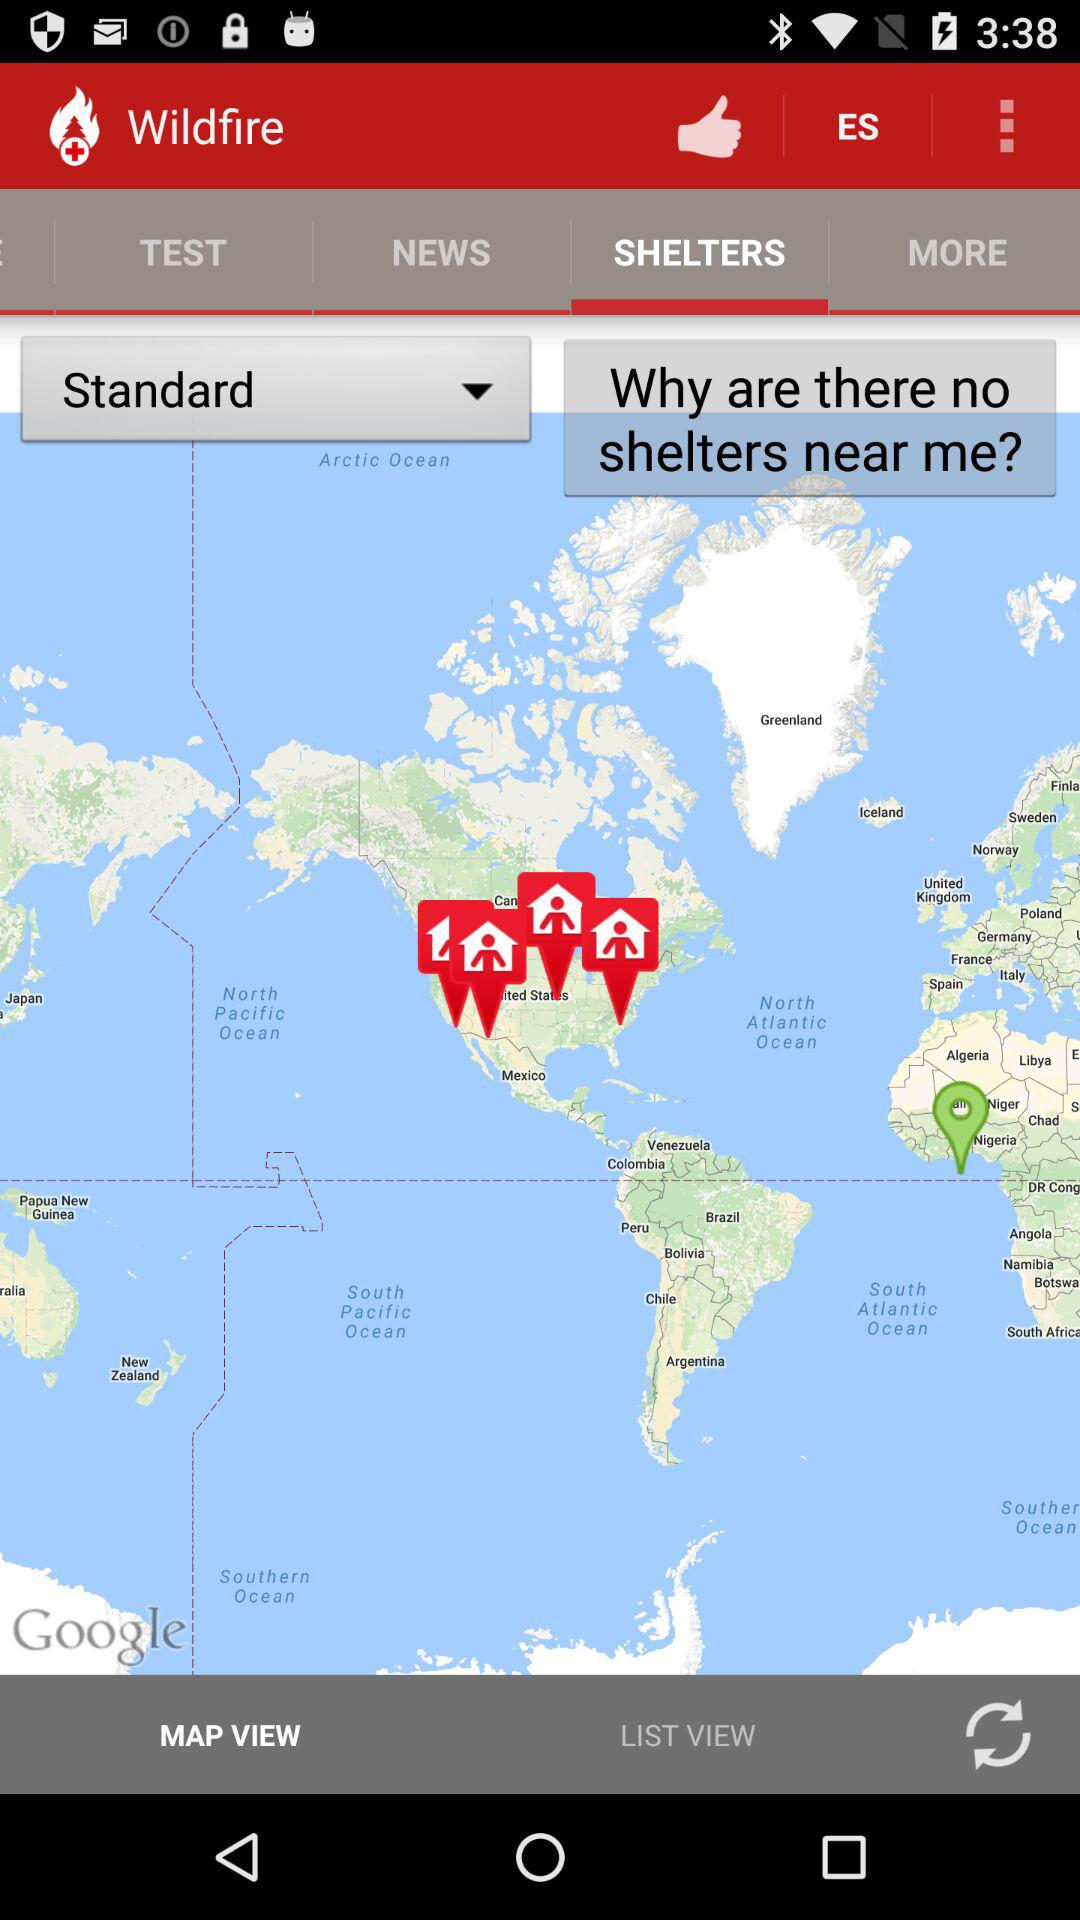What is the application name? The application name is "Wildfire". 